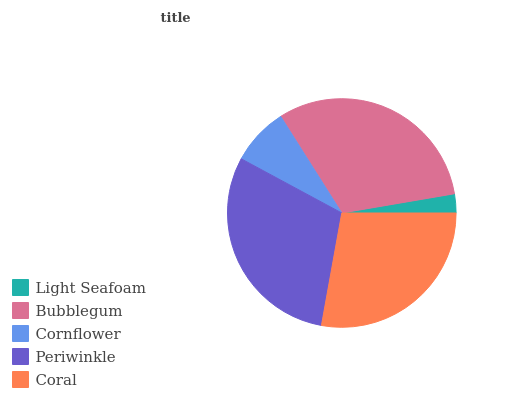Is Light Seafoam the minimum?
Answer yes or no. Yes. Is Bubblegum the maximum?
Answer yes or no. Yes. Is Cornflower the minimum?
Answer yes or no. No. Is Cornflower the maximum?
Answer yes or no. No. Is Bubblegum greater than Cornflower?
Answer yes or no. Yes. Is Cornflower less than Bubblegum?
Answer yes or no. Yes. Is Cornflower greater than Bubblegum?
Answer yes or no. No. Is Bubblegum less than Cornflower?
Answer yes or no. No. Is Coral the high median?
Answer yes or no. Yes. Is Coral the low median?
Answer yes or no. Yes. Is Bubblegum the high median?
Answer yes or no. No. Is Cornflower the low median?
Answer yes or no. No. 